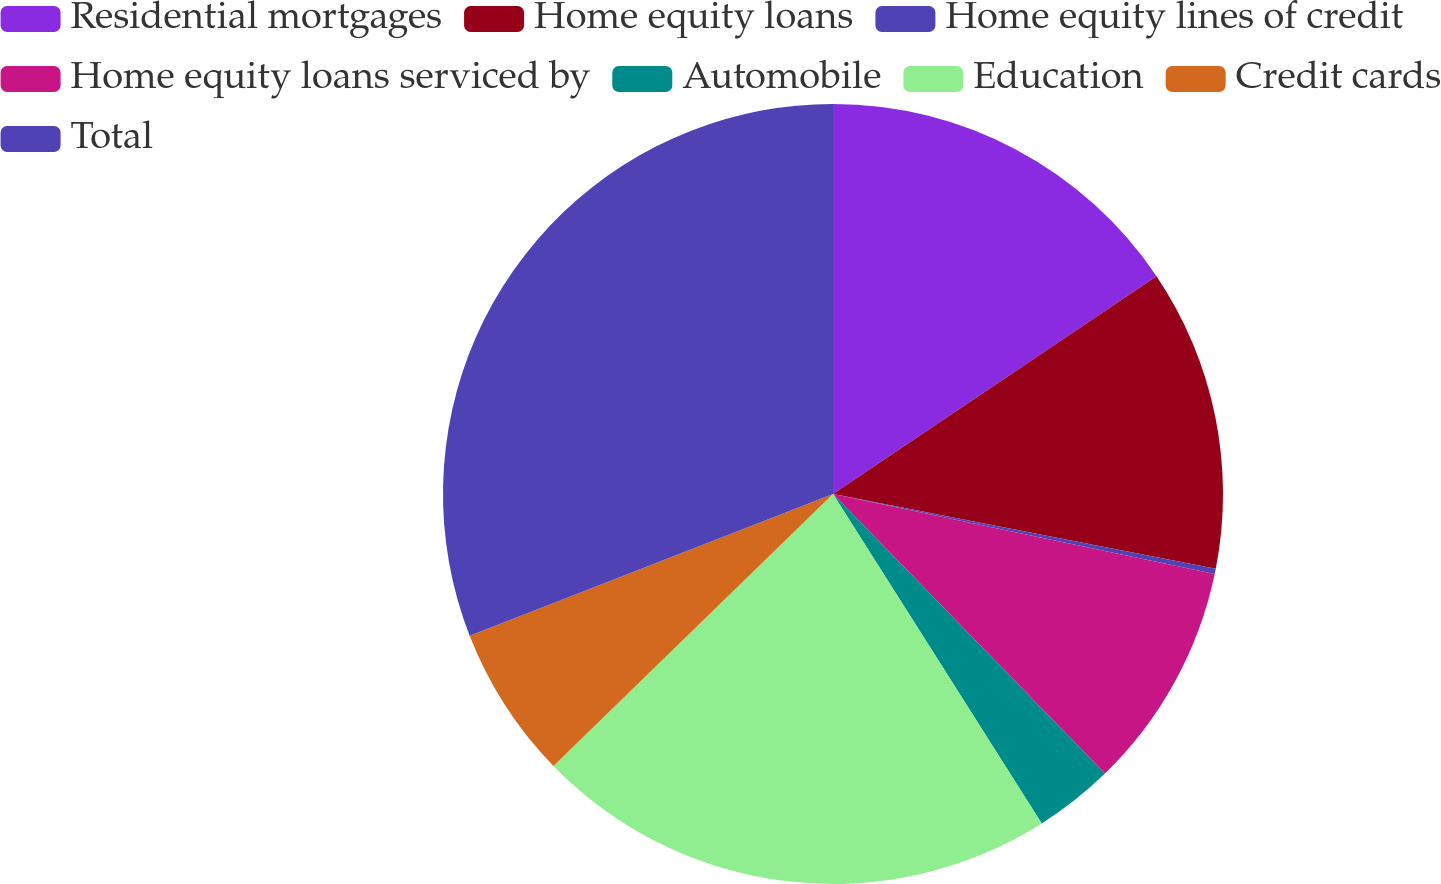<chart> <loc_0><loc_0><loc_500><loc_500><pie_chart><fcel>Residential mortgages<fcel>Home equity loans<fcel>Home equity lines of credit<fcel>Home equity loans serviced by<fcel>Automobile<fcel>Education<fcel>Credit cards<fcel>Total<nl><fcel>15.57%<fcel>12.5%<fcel>0.22%<fcel>9.43%<fcel>3.29%<fcel>21.71%<fcel>6.36%<fcel>30.92%<nl></chart> 